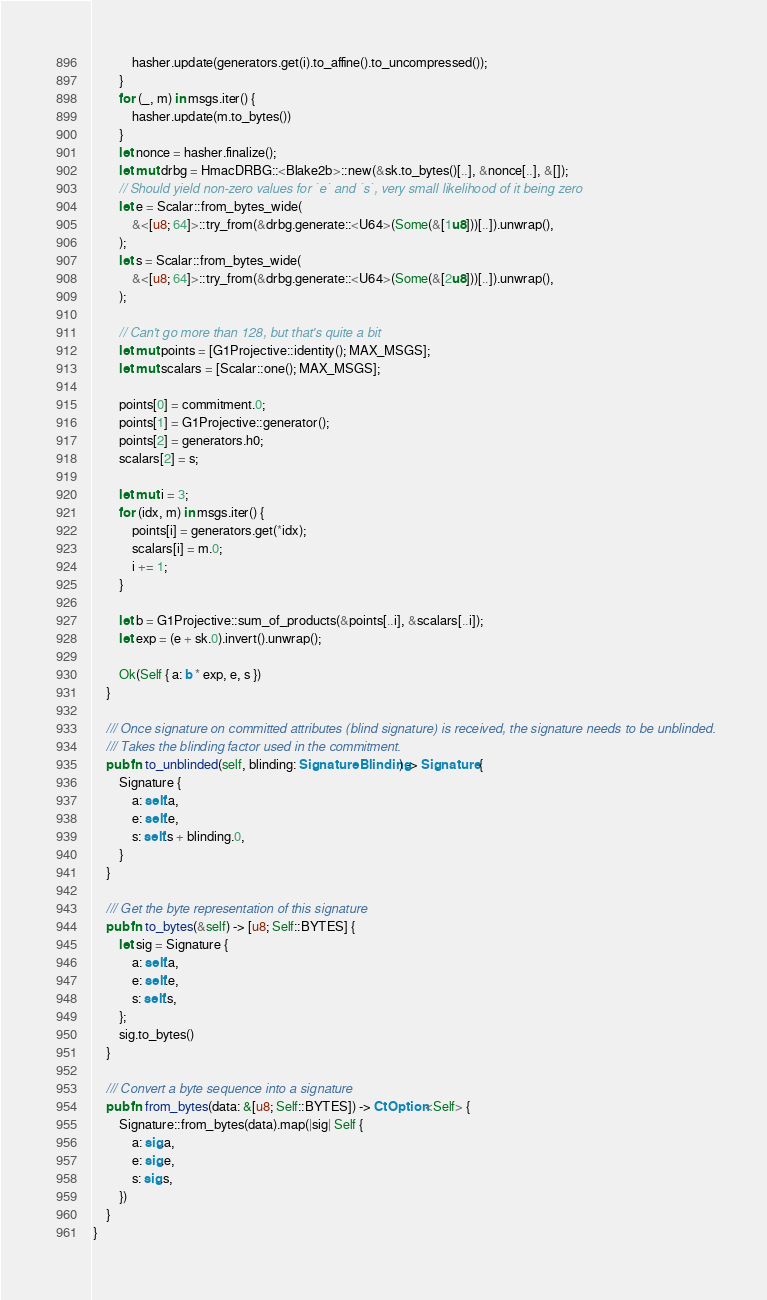Convert code to text. <code><loc_0><loc_0><loc_500><loc_500><_Rust_>            hasher.update(generators.get(i).to_affine().to_uncompressed());
        }
        for (_, m) in msgs.iter() {
            hasher.update(m.to_bytes())
        }
        let nonce = hasher.finalize();
        let mut drbg = HmacDRBG::<Blake2b>::new(&sk.to_bytes()[..], &nonce[..], &[]);
        // Should yield non-zero values for `e` and `s`, very small likelihood of it being zero
        let e = Scalar::from_bytes_wide(
            &<[u8; 64]>::try_from(&drbg.generate::<U64>(Some(&[1u8]))[..]).unwrap(),
        );
        let s = Scalar::from_bytes_wide(
            &<[u8; 64]>::try_from(&drbg.generate::<U64>(Some(&[2u8]))[..]).unwrap(),
        );

        // Can't go more than 128, but that's quite a bit
        let mut points = [G1Projective::identity(); MAX_MSGS];
        let mut scalars = [Scalar::one(); MAX_MSGS];

        points[0] = commitment.0;
        points[1] = G1Projective::generator();
        points[2] = generators.h0;
        scalars[2] = s;

        let mut i = 3;
        for (idx, m) in msgs.iter() {
            points[i] = generators.get(*idx);
            scalars[i] = m.0;
            i += 1;
        }

        let b = G1Projective::sum_of_products(&points[..i], &scalars[..i]);
        let exp = (e + sk.0).invert().unwrap();

        Ok(Self { a: b * exp, e, s })
    }

    /// Once signature on committed attributes (blind signature) is received, the signature needs to be unblinded.
    /// Takes the blinding factor used in the commitment.
    pub fn to_unblinded(self, blinding: SignatureBlinding) -> Signature {
        Signature {
            a: self.a,
            e: self.e,
            s: self.s + blinding.0,
        }
    }

    /// Get the byte representation of this signature
    pub fn to_bytes(&self) -> [u8; Self::BYTES] {
        let sig = Signature {
            a: self.a,
            e: self.e,
            s: self.s,
        };
        sig.to_bytes()
    }

    /// Convert a byte sequence into a signature
    pub fn from_bytes(data: &[u8; Self::BYTES]) -> CtOption<Self> {
        Signature::from_bytes(data).map(|sig| Self {
            a: sig.a,
            e: sig.e,
            s: sig.s,
        })
    }
}
</code> 